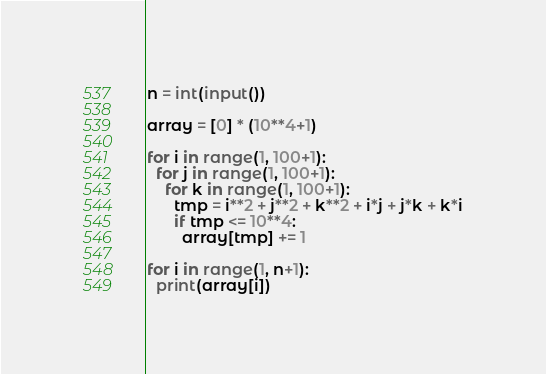<code> <loc_0><loc_0><loc_500><loc_500><_Python_>n = int(input())

array = [0] * (10**4+1)

for i in range(1, 100+1):
  for j in range(1, 100+1):
    for k in range(1, 100+1):
      tmp = i**2 + j**2 + k**2 + i*j + j*k + k*i
      if tmp <= 10**4:
        array[tmp] += 1
        
for i in range(1, n+1):
  print(array[i])</code> 